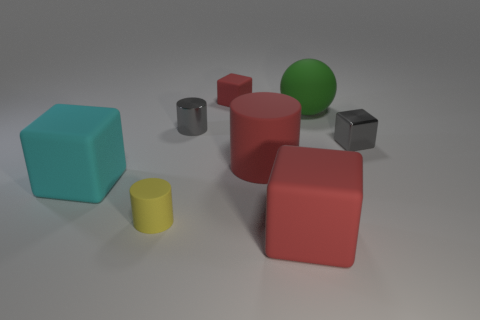What color is the large matte block that is on the left side of the big cube that is in front of the block on the left side of the yellow cylinder?
Your answer should be very brief. Cyan. Do the tiny yellow thing and the gray cylinder have the same material?
Make the answer very short. No. How many brown objects are shiny cylinders or spheres?
Offer a very short reply. 0. What number of things are behind the small gray metal cylinder?
Your response must be concise. 2. Is the number of small gray metallic blocks greater than the number of small cyan matte balls?
Your answer should be very brief. Yes. What shape is the big matte object on the right side of the big red matte block to the right of the large cyan cube?
Provide a succinct answer. Sphere. Is the color of the big sphere the same as the small matte cylinder?
Your response must be concise. No. Are there more large cyan matte cubes that are behind the cyan cube than large yellow metal objects?
Give a very brief answer. No. There is a gray object on the left side of the small red rubber block; what number of tiny gray metallic objects are in front of it?
Offer a terse response. 1. Does the big block that is to the right of the small rubber cylinder have the same material as the big cyan block in front of the green matte sphere?
Offer a terse response. Yes. 